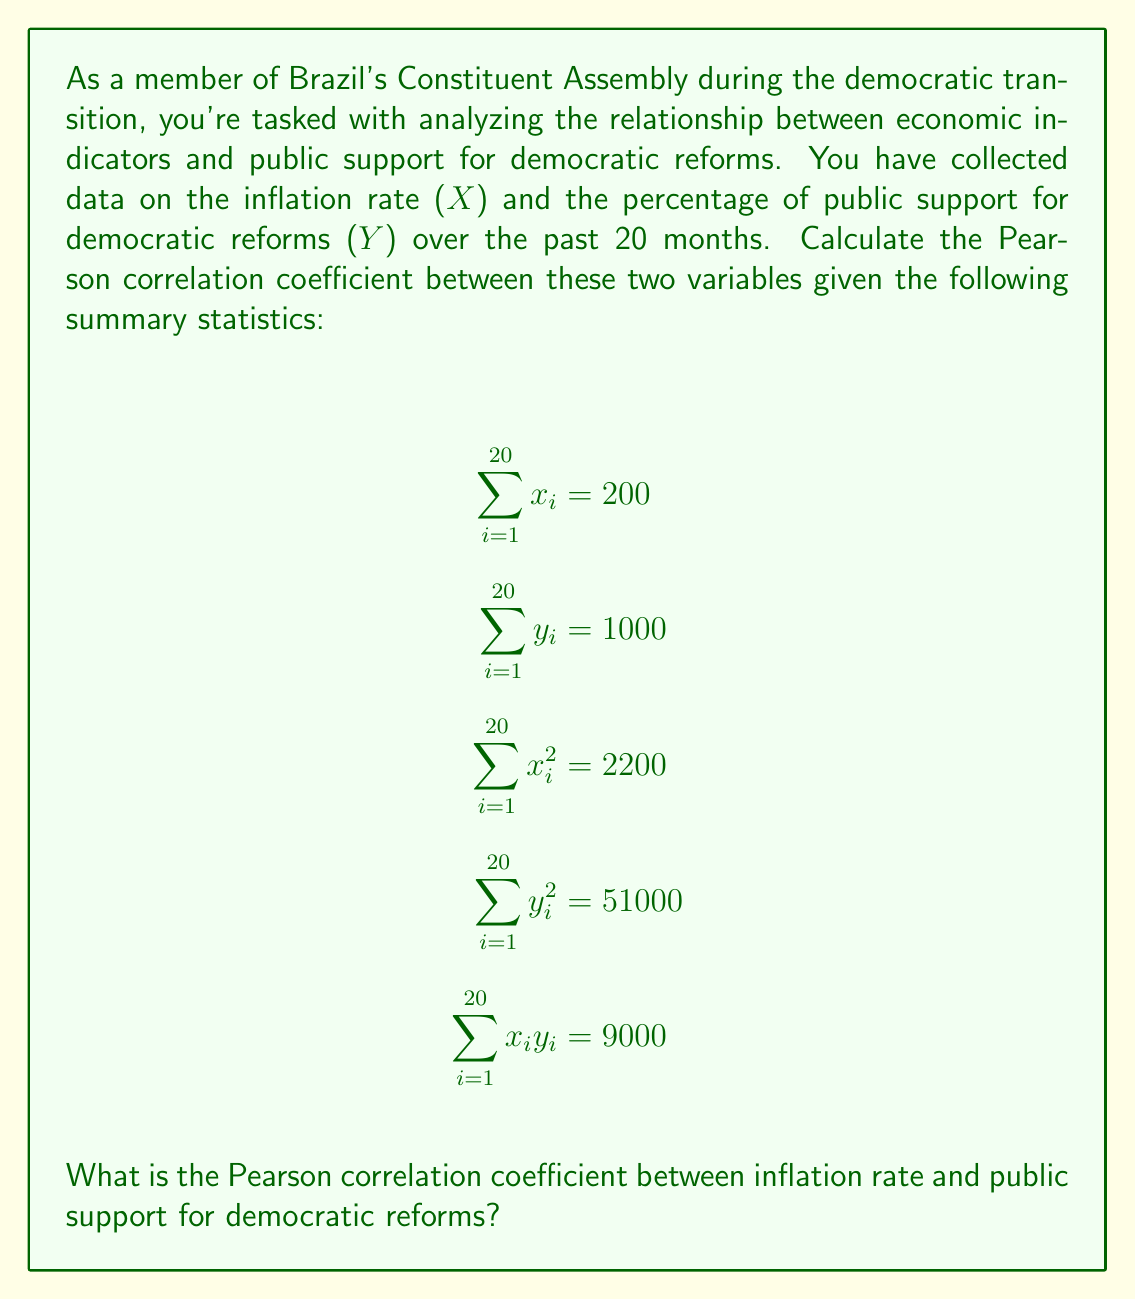Provide a solution to this math problem. To calculate the Pearson correlation coefficient (r), we'll use the formula:

$$ r = \frac{n\sum xy - (\sum x)(\sum y)}{\sqrt{[n\sum x^2 - (\sum x)^2][n\sum y^2 - (\sum y)^2]}} $$

Where:
n = number of observations (20 months)
x = inflation rate
y = percentage of public support for democratic reforms

Step 1: Calculate the numerator
$$ n\sum xy - (\sum x)(\sum y) = 20(9000) - (200)(1000) = 180000 - 200000 = -20000 $$

Step 2: Calculate the first part of the denominator
$$ n\sum x^2 - (\sum x)^2 = 20(2200) - (200)^2 = 44000 - 40000 = 4000 $$

Step 3: Calculate the second part of the denominator
$$ n\sum y^2 - (\sum y)^2 = 20(51000) - (1000)^2 = 1020000 - 1000000 = 20000 $$

Step 4: Multiply the results from steps 2 and 3
$$ 4000 * 20000 = 80000000 $$

Step 5: Take the square root of the result from step 4
$$ \sqrt{80000000} = 8944.27 $$

Step 6: Divide the result from step 1 by the result from step 5
$$ r = \frac{-20000}{8944.27} = -2.23609 $$
Answer: The Pearson correlation coefficient between inflation rate and public support for democratic reforms is approximately $-0.2236$ (rounded to four decimal places). 